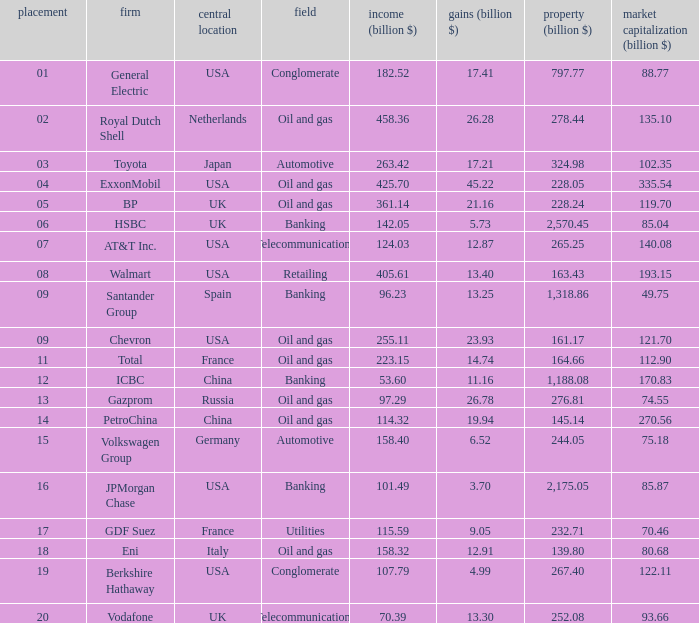Could you parse the entire table as a dict? {'header': ['placement', 'firm', 'central location', 'field', 'income (billion $)', 'gains (billion $)', 'property (billion $)', 'market capitalization (billion $)'], 'rows': [['01', 'General Electric', 'USA', 'Conglomerate', '182.52', '17.41', '797.77', '88.77'], ['02', 'Royal Dutch Shell', 'Netherlands', 'Oil and gas', '458.36', '26.28', '278.44', '135.10'], ['03', 'Toyota', 'Japan', 'Automotive', '263.42', '17.21', '324.98', '102.35'], ['04', 'ExxonMobil', 'USA', 'Oil and gas', '425.70', '45.22', '228.05', '335.54'], ['05', 'BP', 'UK', 'Oil and gas', '361.14', '21.16', '228.24', '119.70'], ['06', 'HSBC', 'UK', 'Banking', '142.05', '5.73', '2,570.45', '85.04'], ['07', 'AT&T Inc.', 'USA', 'Telecommunications', '124.03', '12.87', '265.25', '140.08'], ['08', 'Walmart', 'USA', 'Retailing', '405.61', '13.40', '163.43', '193.15'], ['09', 'Santander Group', 'Spain', 'Banking', '96.23', '13.25', '1,318.86', '49.75'], ['09', 'Chevron', 'USA', 'Oil and gas', '255.11', '23.93', '161.17', '121.70'], ['11', 'Total', 'France', 'Oil and gas', '223.15', '14.74', '164.66', '112.90'], ['12', 'ICBC', 'China', 'Banking', '53.60', '11.16', '1,188.08', '170.83'], ['13', 'Gazprom', 'Russia', 'Oil and gas', '97.29', '26.78', '276.81', '74.55'], ['14', 'PetroChina', 'China', 'Oil and gas', '114.32', '19.94', '145.14', '270.56'], ['15', 'Volkswagen Group', 'Germany', 'Automotive', '158.40', '6.52', '244.05', '75.18'], ['16', 'JPMorgan Chase', 'USA', 'Banking', '101.49', '3.70', '2,175.05', '85.87'], ['17', 'GDF Suez', 'France', 'Utilities', '115.59', '9.05', '232.71', '70.46'], ['18', 'Eni', 'Italy', 'Oil and gas', '158.32', '12.91', '139.80', '80.68'], ['19', 'Berkshire Hathaway', 'USA', 'Conglomerate', '107.79', '4.99', '267.40', '122.11'], ['20', 'Vodafone', 'UK', 'Telecommunications', '70.39', '13.30', '252.08', '93.66']]} Name the highest Profits (billion $) which has a Company of walmart? 13.4. 